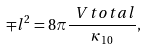Convert formula to latex. <formula><loc_0><loc_0><loc_500><loc_500>\mp l ^ { 2 } = 8 \pi \frac { \ V t o t a l } { \kappa _ { 1 0 } } ,</formula> 